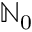<formula> <loc_0><loc_0><loc_500><loc_500>{ \mathbb { N } } _ { 0 }</formula> 